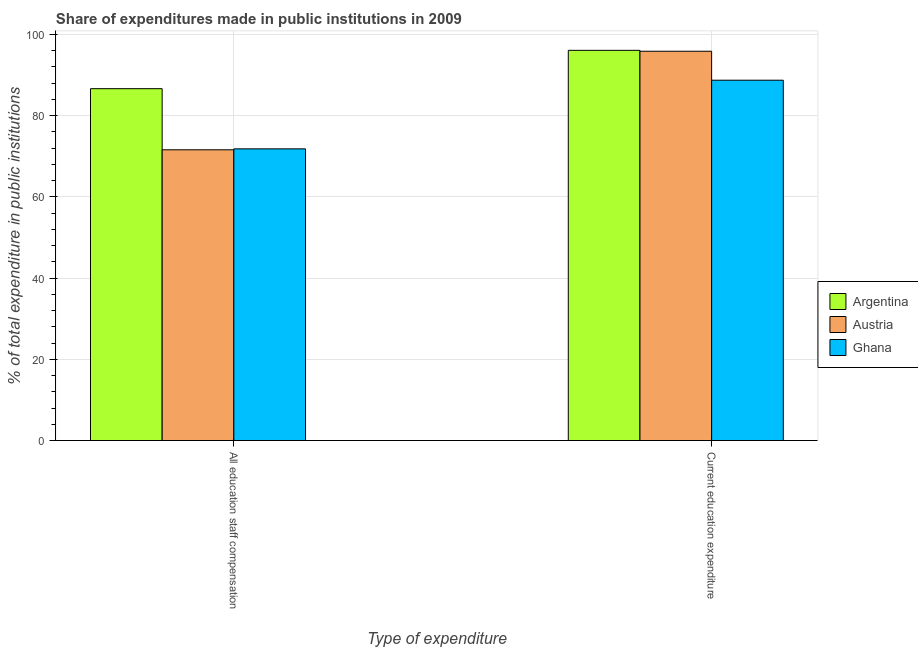How many different coloured bars are there?
Ensure brevity in your answer.  3. Are the number of bars per tick equal to the number of legend labels?
Ensure brevity in your answer.  Yes. Are the number of bars on each tick of the X-axis equal?
Give a very brief answer. Yes. How many bars are there on the 1st tick from the right?
Give a very brief answer. 3. What is the label of the 2nd group of bars from the left?
Your answer should be very brief. Current education expenditure. What is the expenditure in staff compensation in Argentina?
Provide a short and direct response. 86.61. Across all countries, what is the maximum expenditure in staff compensation?
Give a very brief answer. 86.61. Across all countries, what is the minimum expenditure in staff compensation?
Keep it short and to the point. 71.57. In which country was the expenditure in education maximum?
Ensure brevity in your answer.  Argentina. What is the total expenditure in education in the graph?
Ensure brevity in your answer.  280.57. What is the difference between the expenditure in education in Austria and that in Argentina?
Your answer should be very brief. -0.22. What is the difference between the expenditure in education in Austria and the expenditure in staff compensation in Ghana?
Keep it short and to the point. 24.02. What is the average expenditure in staff compensation per country?
Your response must be concise. 76.66. What is the difference between the expenditure in education and expenditure in staff compensation in Ghana?
Offer a terse response. 16.89. In how many countries, is the expenditure in staff compensation greater than 96 %?
Your answer should be compact. 0. What is the ratio of the expenditure in education in Ghana to that in Argentina?
Provide a succinct answer. 0.92. Is the expenditure in staff compensation in Argentina less than that in Ghana?
Give a very brief answer. No. In how many countries, is the expenditure in staff compensation greater than the average expenditure in staff compensation taken over all countries?
Your response must be concise. 1. What does the 1st bar from the left in All education staff compensation represents?
Give a very brief answer. Argentina. How many bars are there?
Give a very brief answer. 6. Are all the bars in the graph horizontal?
Keep it short and to the point. No. How many countries are there in the graph?
Provide a short and direct response. 3. What is the difference between two consecutive major ticks on the Y-axis?
Ensure brevity in your answer.  20. Are the values on the major ticks of Y-axis written in scientific E-notation?
Your answer should be compact. No. Does the graph contain any zero values?
Provide a succinct answer. No. Where does the legend appear in the graph?
Offer a terse response. Center right. How many legend labels are there?
Make the answer very short. 3. What is the title of the graph?
Offer a very short reply. Share of expenditures made in public institutions in 2009. Does "Bermuda" appear as one of the legend labels in the graph?
Ensure brevity in your answer.  No. What is the label or title of the X-axis?
Offer a terse response. Type of expenditure. What is the label or title of the Y-axis?
Your response must be concise. % of total expenditure in public institutions. What is the % of total expenditure in public institutions in Argentina in All education staff compensation?
Keep it short and to the point. 86.61. What is the % of total expenditure in public institutions in Austria in All education staff compensation?
Provide a succinct answer. 71.57. What is the % of total expenditure in public institutions in Ghana in All education staff compensation?
Offer a very short reply. 71.8. What is the % of total expenditure in public institutions in Argentina in Current education expenditure?
Your answer should be very brief. 96.05. What is the % of total expenditure in public institutions of Austria in Current education expenditure?
Make the answer very short. 95.83. What is the % of total expenditure in public institutions in Ghana in Current education expenditure?
Give a very brief answer. 88.7. Across all Type of expenditure, what is the maximum % of total expenditure in public institutions of Argentina?
Make the answer very short. 96.05. Across all Type of expenditure, what is the maximum % of total expenditure in public institutions in Austria?
Ensure brevity in your answer.  95.83. Across all Type of expenditure, what is the maximum % of total expenditure in public institutions in Ghana?
Ensure brevity in your answer.  88.7. Across all Type of expenditure, what is the minimum % of total expenditure in public institutions in Argentina?
Provide a succinct answer. 86.61. Across all Type of expenditure, what is the minimum % of total expenditure in public institutions of Austria?
Your answer should be compact. 71.57. Across all Type of expenditure, what is the minimum % of total expenditure in public institutions in Ghana?
Your response must be concise. 71.8. What is the total % of total expenditure in public institutions in Argentina in the graph?
Your answer should be very brief. 182.66. What is the total % of total expenditure in public institutions of Austria in the graph?
Give a very brief answer. 167.4. What is the total % of total expenditure in public institutions of Ghana in the graph?
Give a very brief answer. 160.5. What is the difference between the % of total expenditure in public institutions in Argentina in All education staff compensation and that in Current education expenditure?
Provide a short and direct response. -9.44. What is the difference between the % of total expenditure in public institutions of Austria in All education staff compensation and that in Current education expenditure?
Your answer should be compact. -24.26. What is the difference between the % of total expenditure in public institutions of Ghana in All education staff compensation and that in Current education expenditure?
Your answer should be very brief. -16.89. What is the difference between the % of total expenditure in public institutions in Argentina in All education staff compensation and the % of total expenditure in public institutions in Austria in Current education expenditure?
Your answer should be compact. -9.21. What is the difference between the % of total expenditure in public institutions of Argentina in All education staff compensation and the % of total expenditure in public institutions of Ghana in Current education expenditure?
Keep it short and to the point. -2.08. What is the difference between the % of total expenditure in public institutions of Austria in All education staff compensation and the % of total expenditure in public institutions of Ghana in Current education expenditure?
Provide a succinct answer. -17.13. What is the average % of total expenditure in public institutions of Argentina per Type of expenditure?
Provide a short and direct response. 91.33. What is the average % of total expenditure in public institutions in Austria per Type of expenditure?
Your answer should be very brief. 83.7. What is the average % of total expenditure in public institutions of Ghana per Type of expenditure?
Offer a very short reply. 80.25. What is the difference between the % of total expenditure in public institutions in Argentina and % of total expenditure in public institutions in Austria in All education staff compensation?
Your answer should be very brief. 15.04. What is the difference between the % of total expenditure in public institutions in Argentina and % of total expenditure in public institutions in Ghana in All education staff compensation?
Your answer should be very brief. 14.81. What is the difference between the % of total expenditure in public institutions of Austria and % of total expenditure in public institutions of Ghana in All education staff compensation?
Your answer should be compact. -0.23. What is the difference between the % of total expenditure in public institutions of Argentina and % of total expenditure in public institutions of Austria in Current education expenditure?
Offer a very short reply. 0.22. What is the difference between the % of total expenditure in public institutions of Argentina and % of total expenditure in public institutions of Ghana in Current education expenditure?
Make the answer very short. 7.35. What is the difference between the % of total expenditure in public institutions of Austria and % of total expenditure in public institutions of Ghana in Current education expenditure?
Provide a short and direct response. 7.13. What is the ratio of the % of total expenditure in public institutions in Argentina in All education staff compensation to that in Current education expenditure?
Give a very brief answer. 0.9. What is the ratio of the % of total expenditure in public institutions of Austria in All education staff compensation to that in Current education expenditure?
Your response must be concise. 0.75. What is the ratio of the % of total expenditure in public institutions in Ghana in All education staff compensation to that in Current education expenditure?
Ensure brevity in your answer.  0.81. What is the difference between the highest and the second highest % of total expenditure in public institutions in Argentina?
Give a very brief answer. 9.44. What is the difference between the highest and the second highest % of total expenditure in public institutions of Austria?
Offer a terse response. 24.26. What is the difference between the highest and the second highest % of total expenditure in public institutions of Ghana?
Your answer should be compact. 16.89. What is the difference between the highest and the lowest % of total expenditure in public institutions of Argentina?
Provide a short and direct response. 9.44. What is the difference between the highest and the lowest % of total expenditure in public institutions of Austria?
Your answer should be very brief. 24.26. What is the difference between the highest and the lowest % of total expenditure in public institutions of Ghana?
Provide a succinct answer. 16.89. 